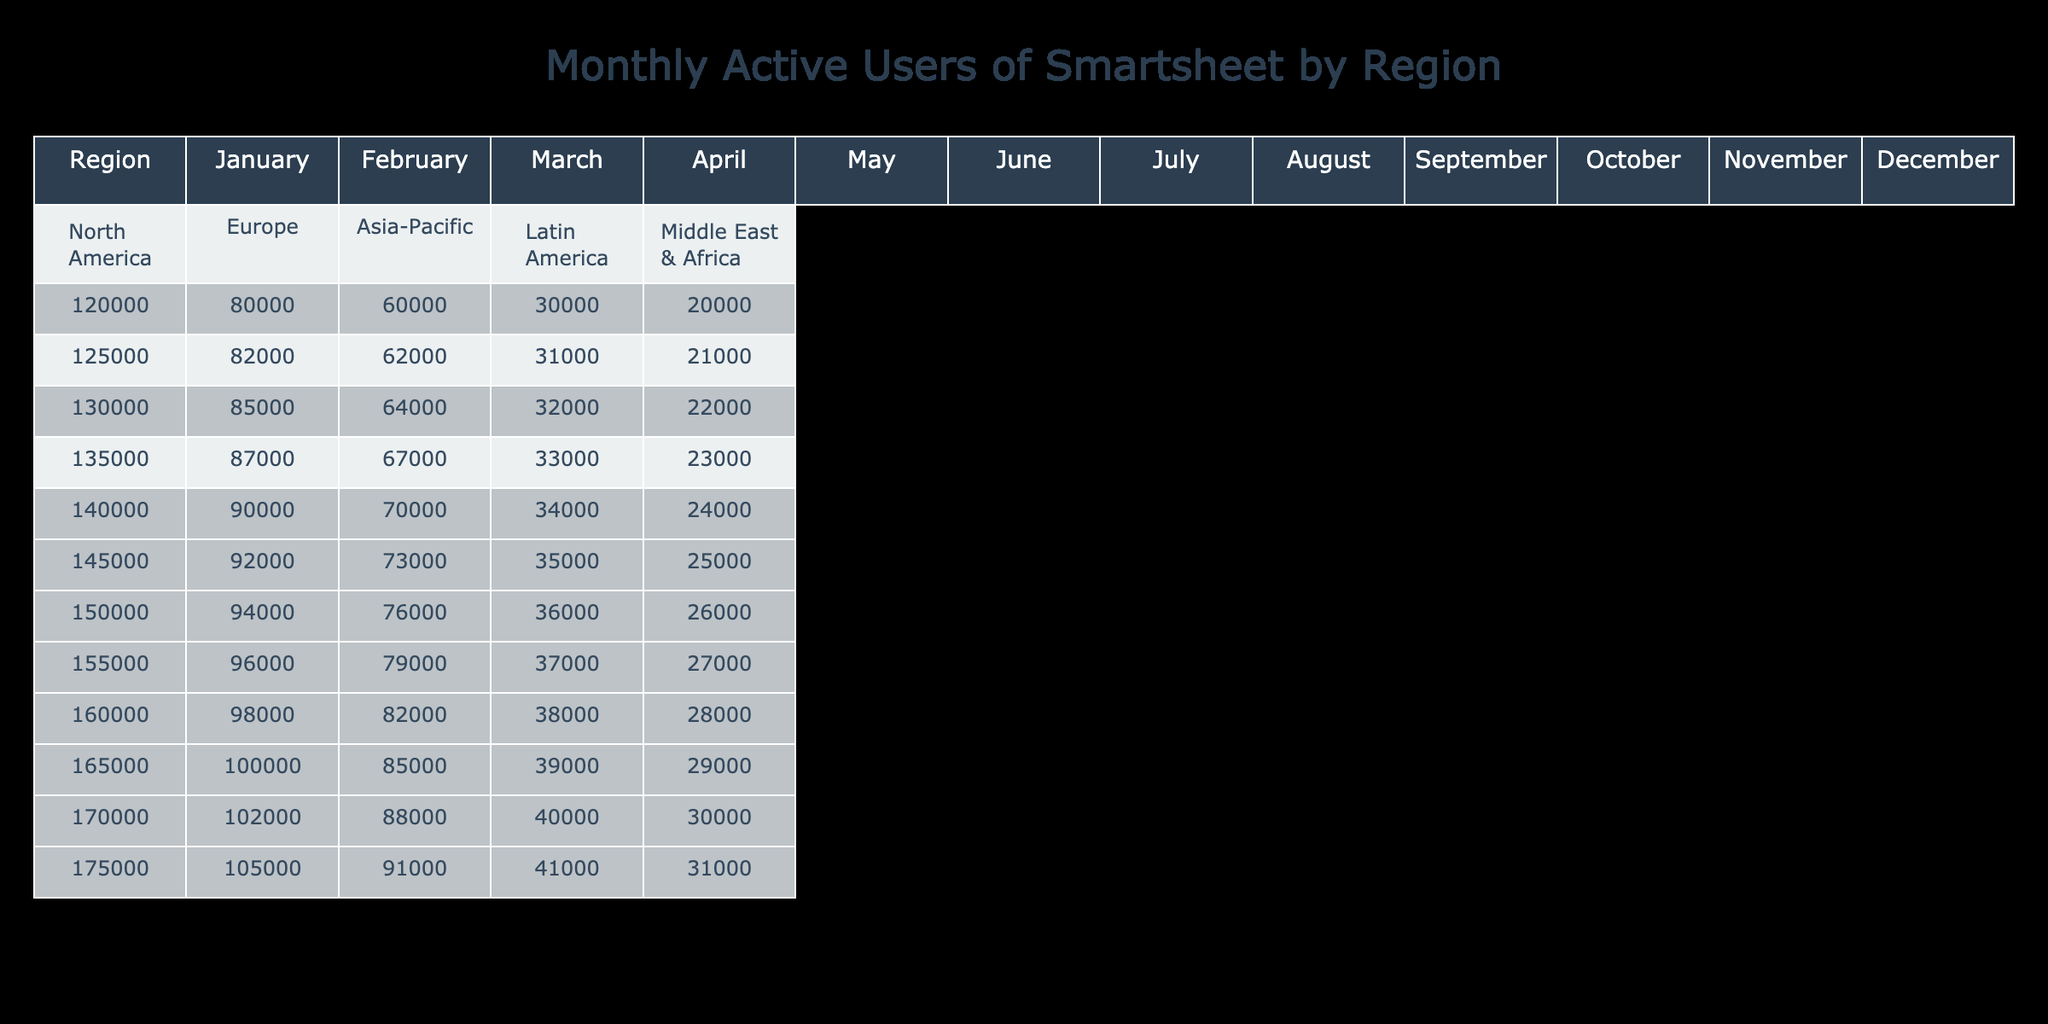What was the highest number of active users for North America in the past year? The highest number of active users for North America can be found by examining the figures for each month. The values increase each month, starting from 120,000 in January and reaching a maximum of 175,000 in December.
Answer: 175,000 In which month did Europe see its lowest number of active users? The lowest number of active users for Europe can be found by looking at the monthly data. The numbers are recorded as (80,000 in January), (82,000 in February), (85,000 in March), and so forth. It shows a steady increase starting from January to December, with the lowest value being 80,000 in January.
Answer: January What is the total number of monthly active users for all regions in May? To find the total, we add the figures for all regions in May: 140,000 (North America) + 90,000 (Europe) + 70,000 (Asia-Pacific) + 34,000 (Latin America) + 24,000 (Middle East & Africa) = 358,000.
Answer: 358,000 Is the number of active users in Asia-Pacific always lower than that of Europe throughout the year? To answer this, we evaluate the numbers for Asia-Pacific and compare them to Europe month by month. The Asia-Pacific region starts with 60,000 in January and generally grows to 91,000 in December, while Europe starts at 80,000 and ends at 105,000, indicating Asia-Pacific users are less than Europe only until April. In May, Asia-Pacific's users catch up and grow larger in the following months. Thus, it's not always lower.
Answer: No What is the average number of active users for Latin America over the year? To find the average, we first sum up the monthly users in Latin America (30,000 + 31,000 + 32,000 + 33,000 + 34,000 + 35,000 + 36,000 + 37,000 + 38,000 + 39,000 + 40,000 + 41,000) = 405,000. Then, we divide by the number of months, which is 12. Thus, the average is 405,000 / 12 = 33,750.
Answer: 33,750 